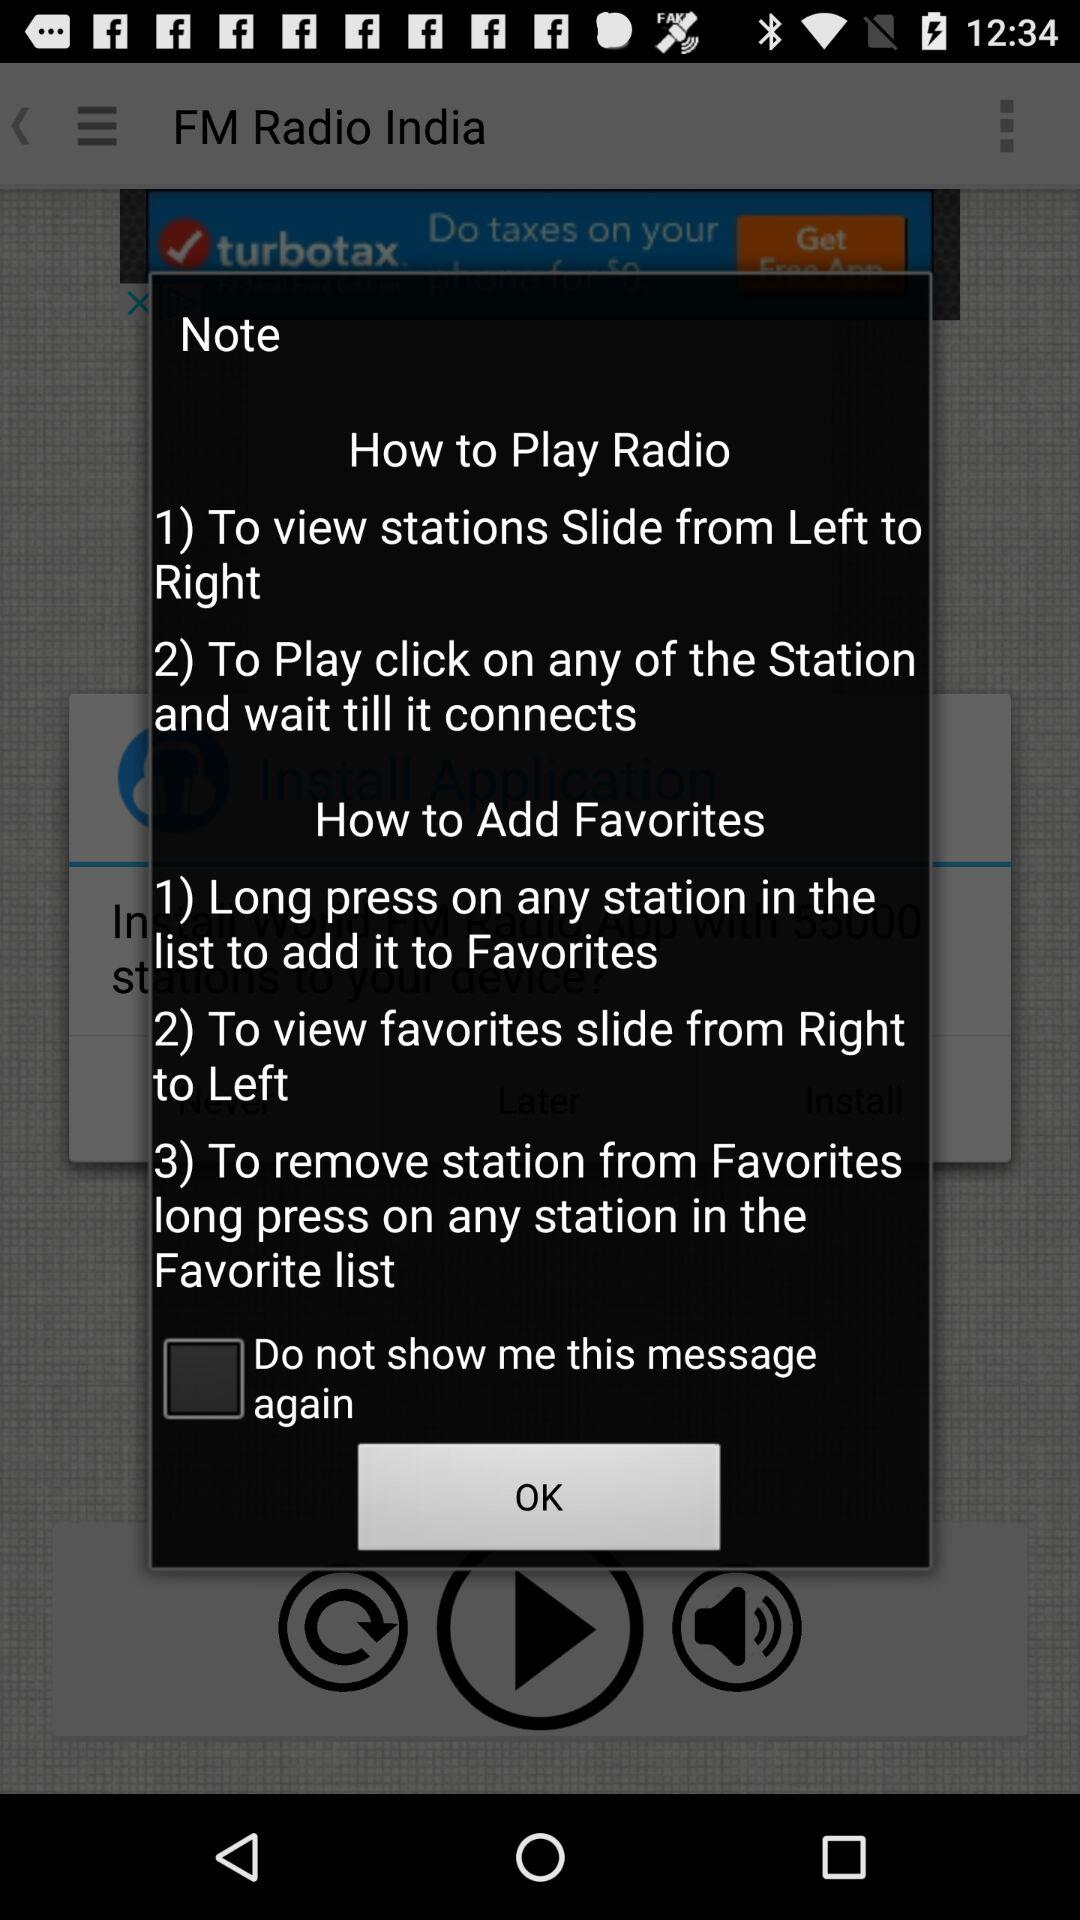How many steps are there to play a radio station?
Answer the question using a single word or phrase. 2 